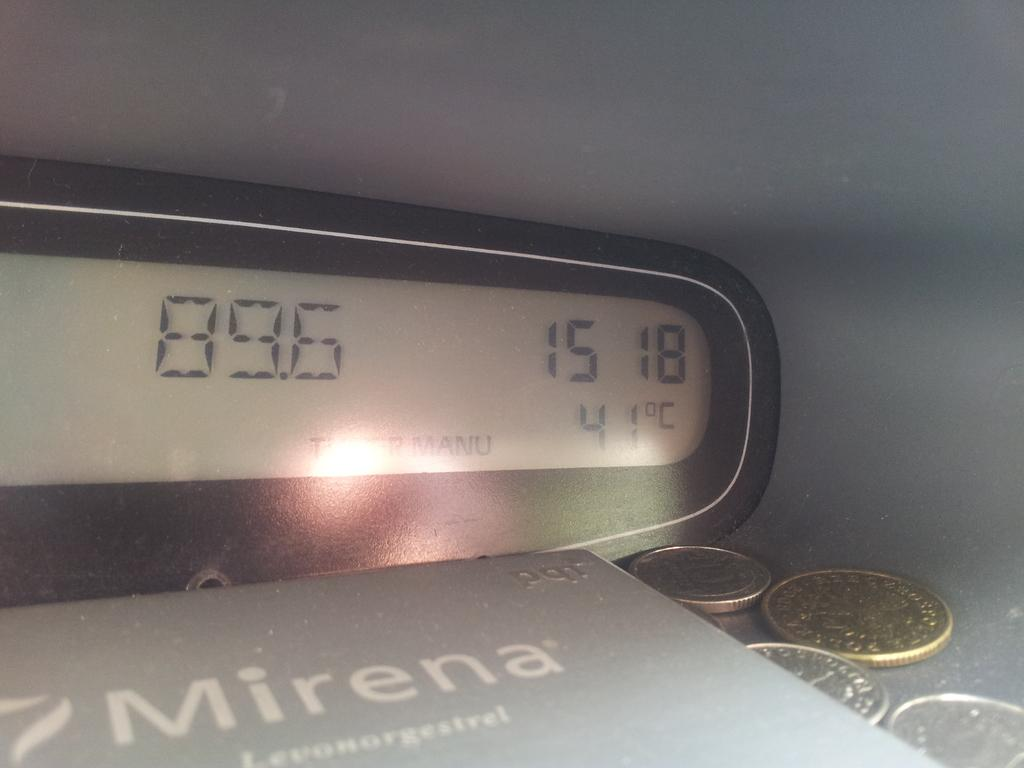What type of device is shown in the image? There is a digital display in the image. What other object is present in the image? There is a box in the image. What can be seen inside the box? Coins are visible in the image. What is the skin condition of the person in the image? There is no person present in the image, so it is not possible to determine their skin condition. 